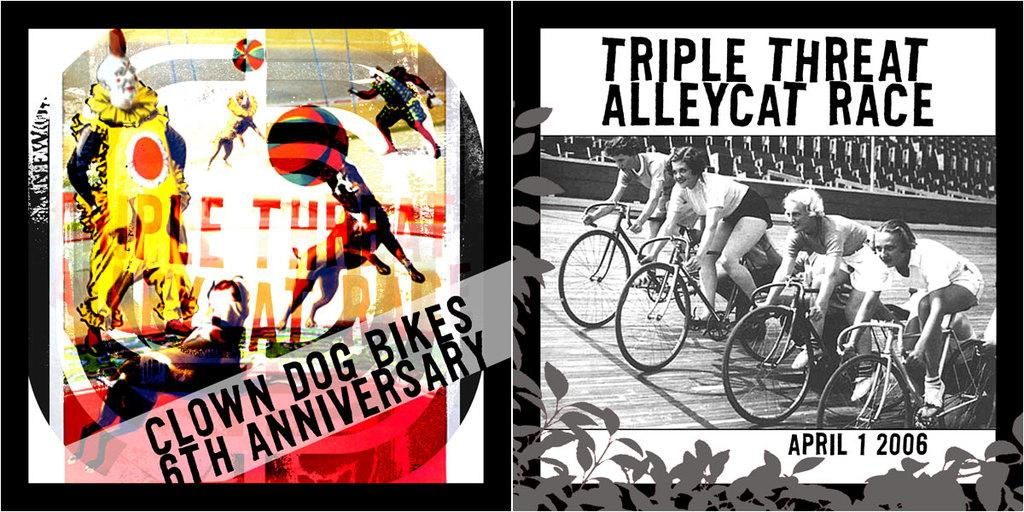<image>
Provide a brief description of the given image. The Triple Threat Alley Race is on April first 2006 